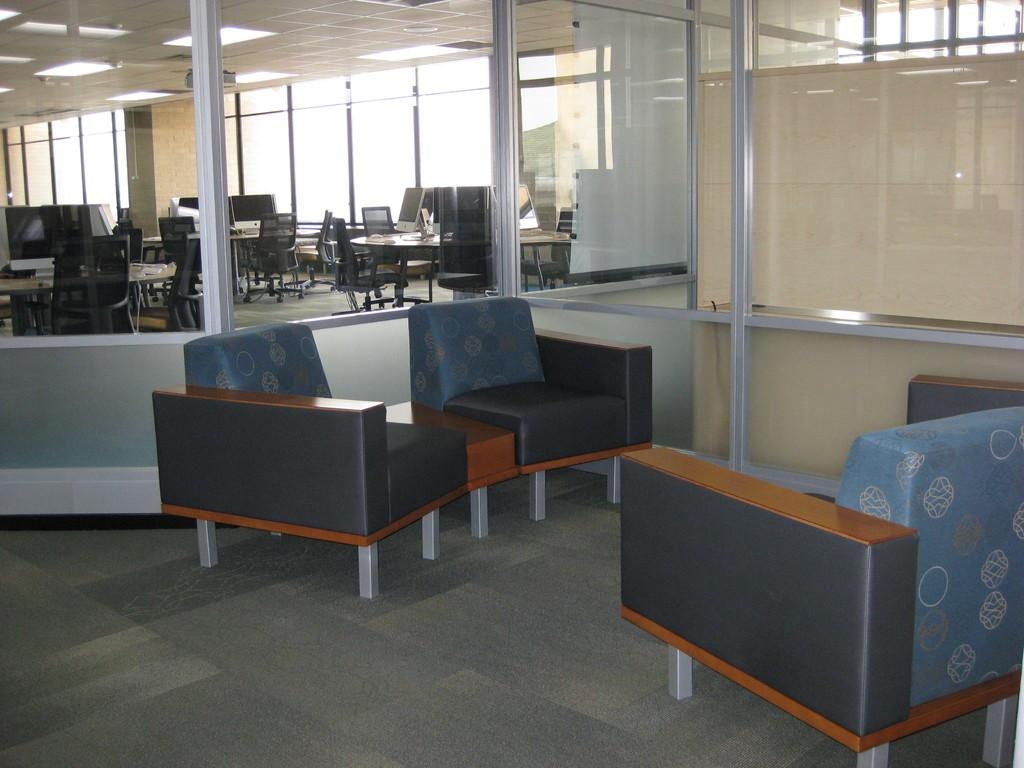Where is the image taken? The image is taken in an office. What type of furniture can be seen in the image? There are chairs and tables in the image. How are the chairs and tables positioned in the image? The chairs and tables are on the floor. What can be seen in the background of the chair? There is a glass window in the background of the chair. What flavor of ink is used in the pen on the table? There is no pen or ink present in the image; only chairs, tables, and a glass window are visible. 